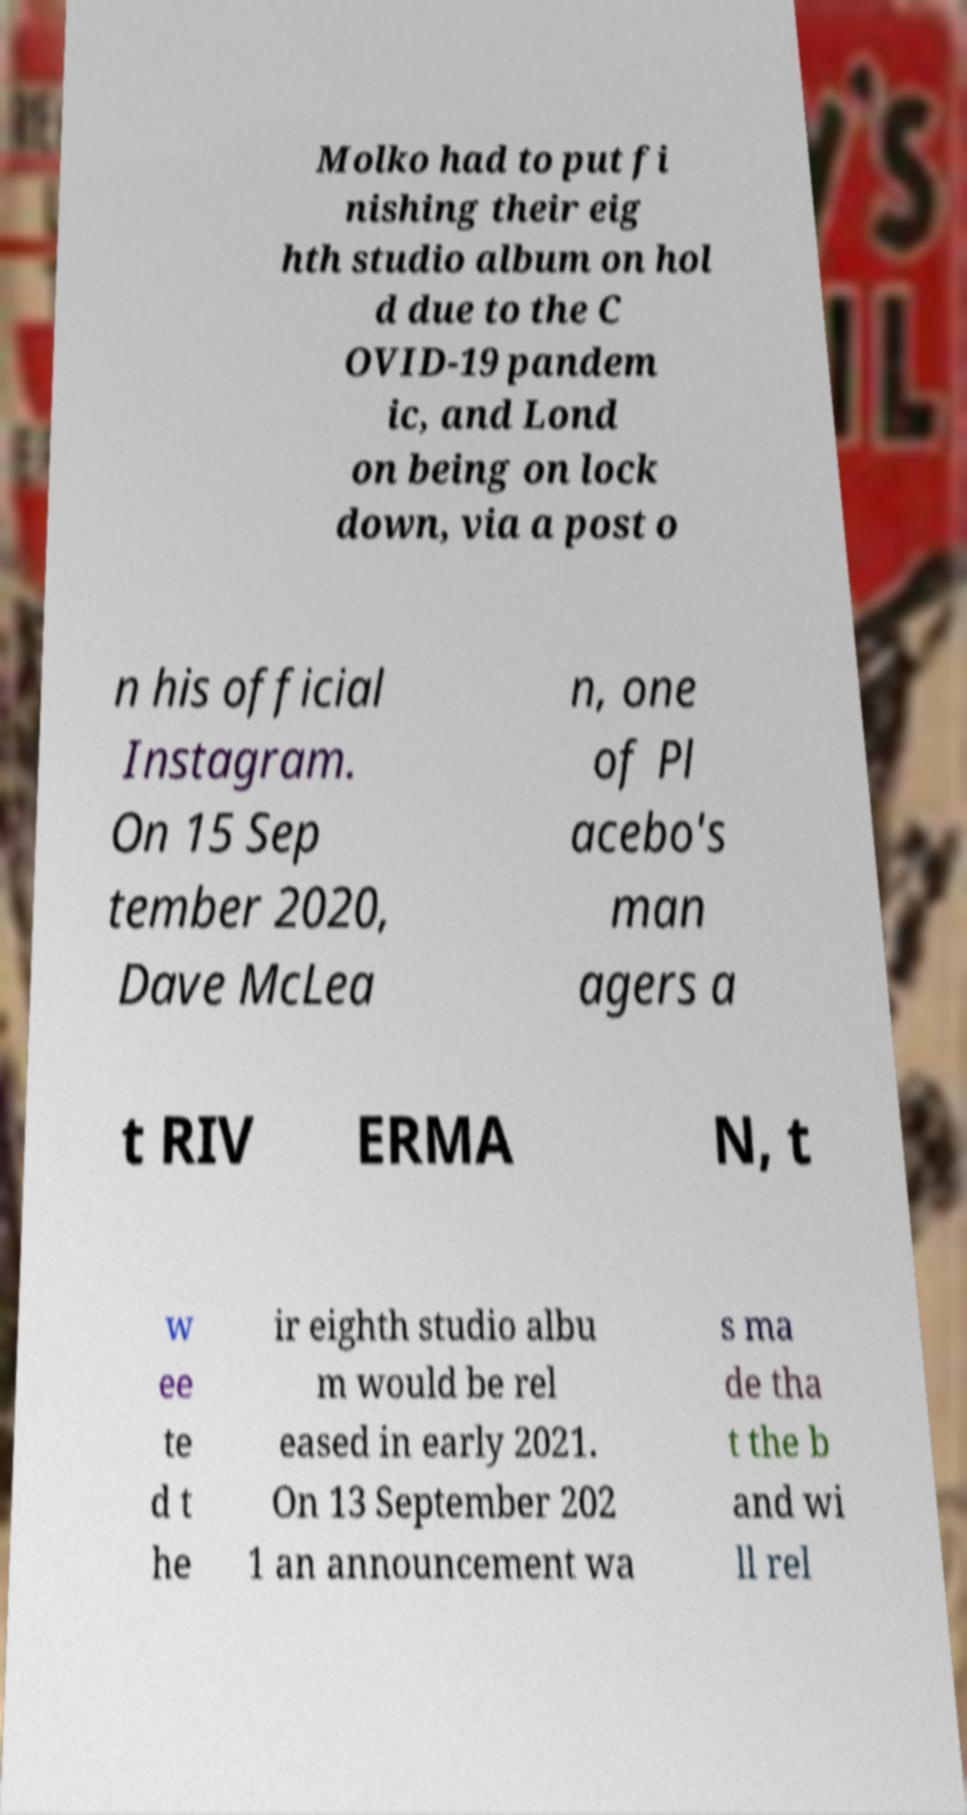I need the written content from this picture converted into text. Can you do that? Molko had to put fi nishing their eig hth studio album on hol d due to the C OVID-19 pandem ic, and Lond on being on lock down, via a post o n his official Instagram. On 15 Sep tember 2020, Dave McLea n, one of Pl acebo's man agers a t RIV ERMA N, t w ee te d t he ir eighth studio albu m would be rel eased in early 2021. On 13 September 202 1 an announcement wa s ma de tha t the b and wi ll rel 